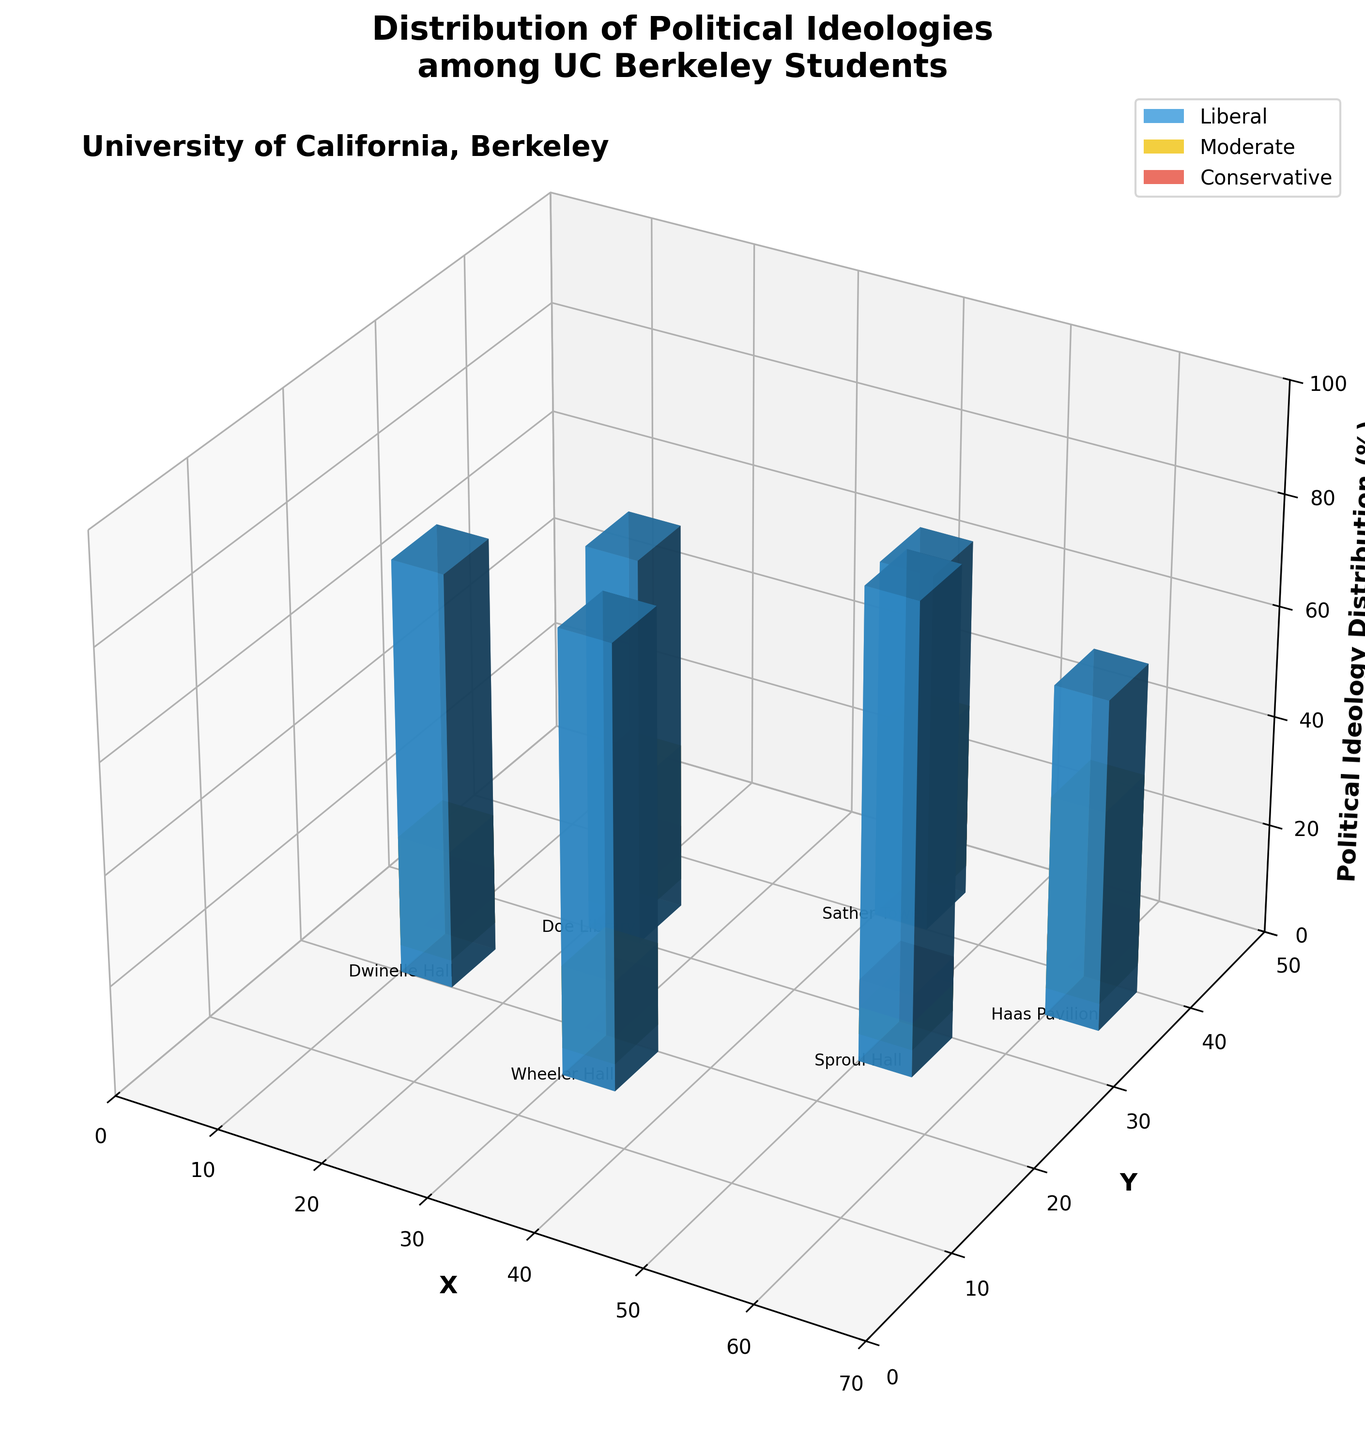What is the title of the figure? The title is usually displayed at the top of the figure. In this case, it is about the political ideologies among UC Berkeley students.
Answer: Distribution of Political Ideologies among UC Berkeley Students What are the different political ideologies represented in the figure? The different political ideologies can be identified by the color legend.
Answer: Liberal, Moderate, Conservative How many buildings are represented in the figure? Each distinct position on the X and Y axis represents a unique building. The figure shows locations for Dwinelle Hall, Wheeler Hall, Doe Library, Sather Tower, Sproul Hall, and Haas Pavilion.
Answer: 6 Which building has the highest percentage of Liberal students? By comparing the heights of the blue bars (which represent Liberal students) at all buildings, the highest is at Sproul Hall.
Answer: Sproul Hall What is the percentage of Conservative students in Wheeler Hall? Following the grid to Wheeler Hall and looking at the height of the red bar, which represents Conservative students, it is 5%.
Answer: 5% Which building has the highest combined percentage of Liberal and Moderate students? To find this, sum the heights of the blue and yellow bars for each building and compare. Sproul Hall has 85% (Liberal) + 10% (Moderate) = 95%, which is the highest.
Answer: Sproul Hall Which building has the least percentage of Moderate students? By comparing the height of the yellow bars across all buildings, Sproul Hall shows the least at 10%.
Answer: Sproul Hall What is the total percentage of students categorized as Liberal in Doe Library and Haas Pavilion together? Sum the heights of the blue bars in both buildings: Doe Library has 70% and Haas Pavilion has 60%, so 70% + 60% = 130%.
Answer: 130% Which building displays the least ideological diversity among students? Ideological diversity can be inferred by having more balanced bar heights among ideologies. The building where one ideology dominates is Sproul Hall with 85% Liberal, 10% Moderate, and 5% Conservative.
Answer: Sproul Hall Compare the distribution of Moderate students between Sather Tower and Haas Pavilion. Look at the height of the yellow bars for both buildings: Sather Tower has 30% Moderate students, while Haas Pavilion has 35%.
Answer: Haas Pavilion has more Moderate students 